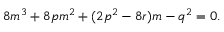<formula> <loc_0><loc_0><loc_500><loc_500>8 m ^ { 3 } + 8 p m ^ { 2 } + ( 2 p ^ { 2 } - 8 r ) m - q ^ { 2 } = 0 .</formula> 